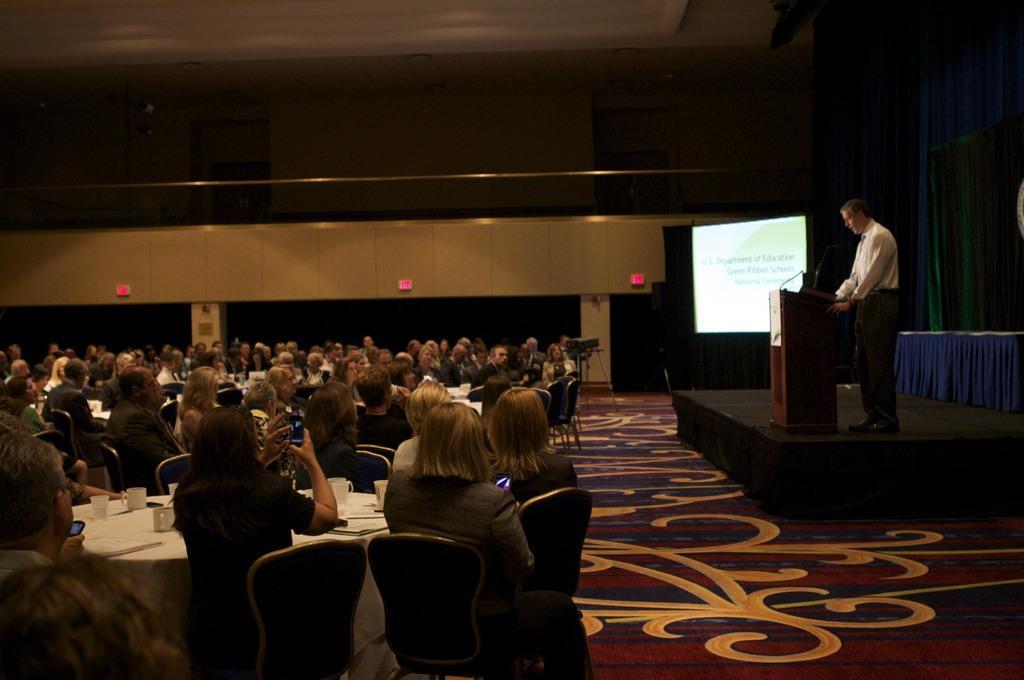Can you describe this image briefly? In this picture group of people sitting on the chair. There is a person standing. This is podium. On the podium we can see microphone. This is Screen. This is curtain. On the background we can see wall,pillar,light. There is a table. On the table we can see glasses and cloth. These two persons holding mobile. This is floor. 